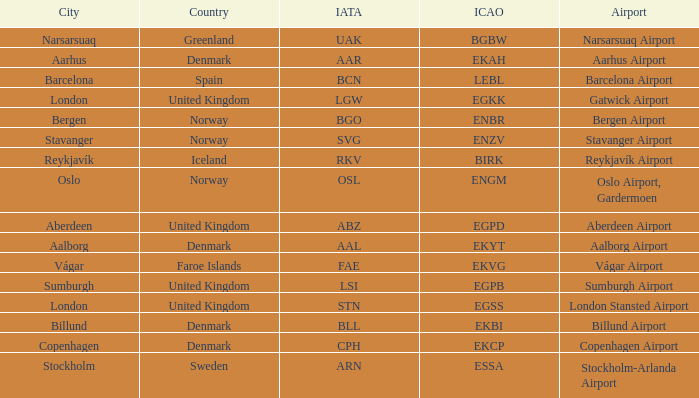What airport has an ICAO of Birk? Reykjavík Airport. 